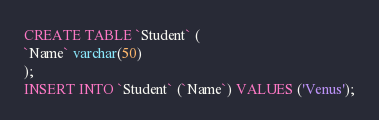Convert code to text. <code><loc_0><loc_0><loc_500><loc_500><_SQL_>CREATE TABLE `Student` (
`Name` varchar(50)
);
INSERT INTO `Student` (`Name`) VALUES ('Venus');
</code> 